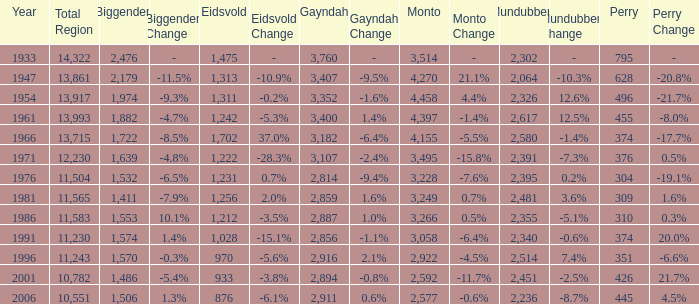Which is the year with Mundubbera being smaller than 2,395, and Biggenden smaller than 1,506? None. 